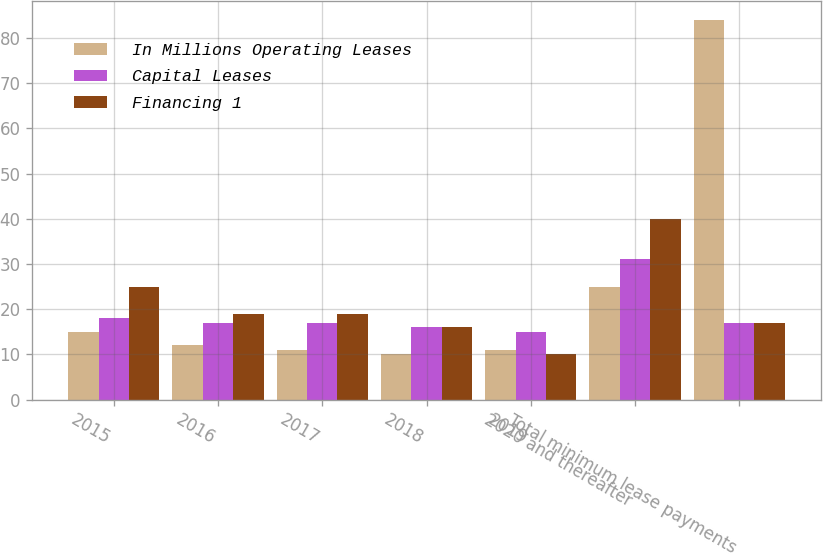Convert chart to OTSL. <chart><loc_0><loc_0><loc_500><loc_500><stacked_bar_chart><ecel><fcel>2015<fcel>2016<fcel>2017<fcel>2018<fcel>2019<fcel>2020 and thereafter<fcel>Total minimum lease payments<nl><fcel>In Millions Operating Leases<fcel>15<fcel>12<fcel>11<fcel>10<fcel>11<fcel>25<fcel>84<nl><fcel>Capital Leases<fcel>18<fcel>17<fcel>17<fcel>16<fcel>15<fcel>31<fcel>17<nl><fcel>Financing 1<fcel>25<fcel>19<fcel>19<fcel>16<fcel>10<fcel>40<fcel>17<nl></chart> 